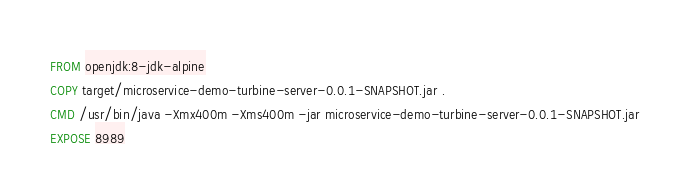Convert code to text. <code><loc_0><loc_0><loc_500><loc_500><_Dockerfile_>FROM openjdk:8-jdk-alpine
COPY target/microservice-demo-turbine-server-0.0.1-SNAPSHOT.jar .
CMD /usr/bin/java -Xmx400m -Xms400m -jar microservice-demo-turbine-server-0.0.1-SNAPSHOT.jar
EXPOSE 8989
</code> 